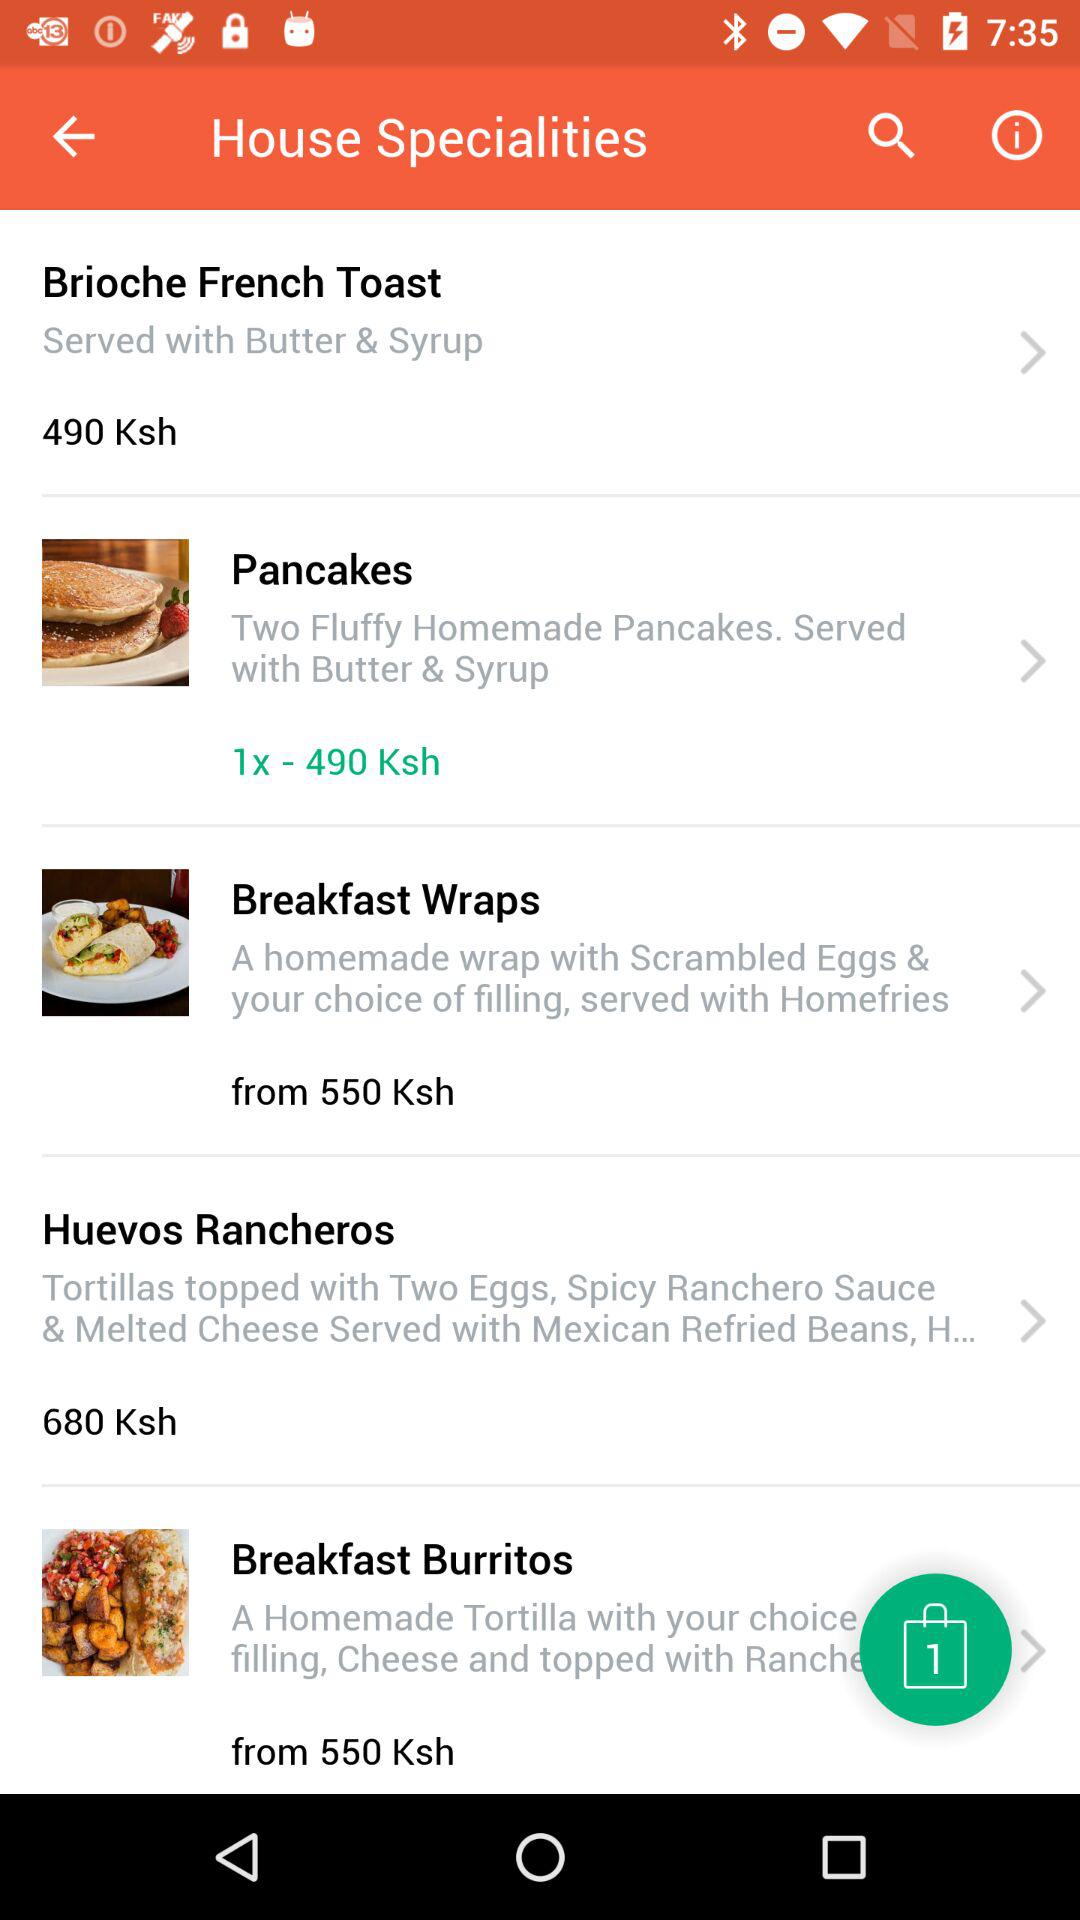How will brioche French toast be served? Brioche French toast will be served with butter and syrup. 